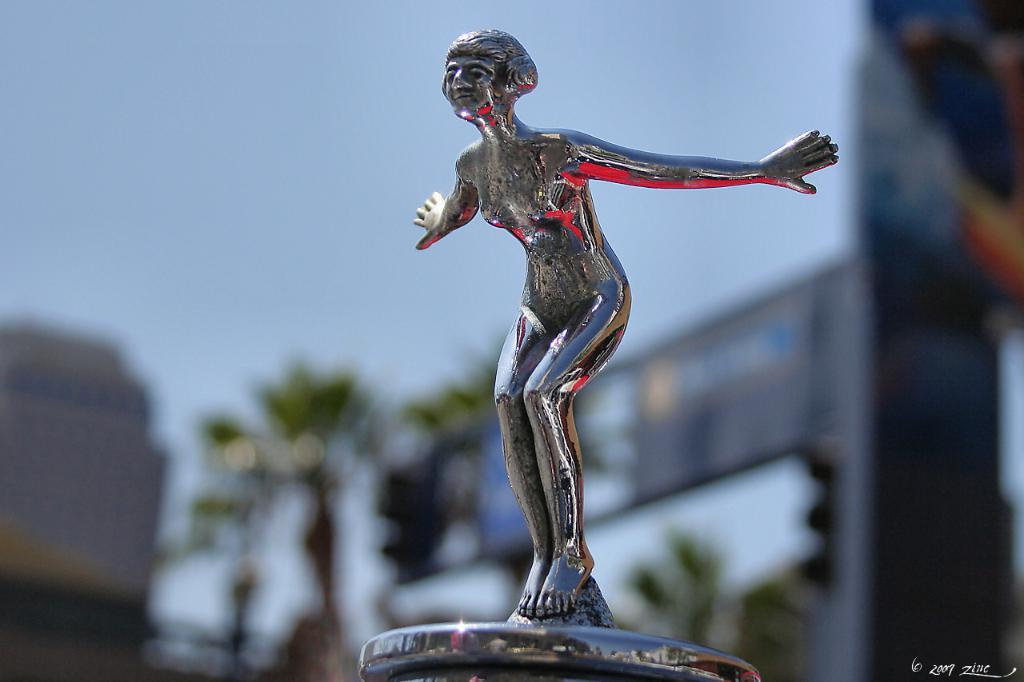What is the main subject of the image? There is a sculpture of a woman in the center of the image. Can you describe the background of the image? The background of the image is blurred. What type of plant is growing near the sculpture in the image? There is no plant visible near the sculpture in the image. What is the sculpture's interest in sailing? The sculpture is not a real person and therefore cannot have interests. 